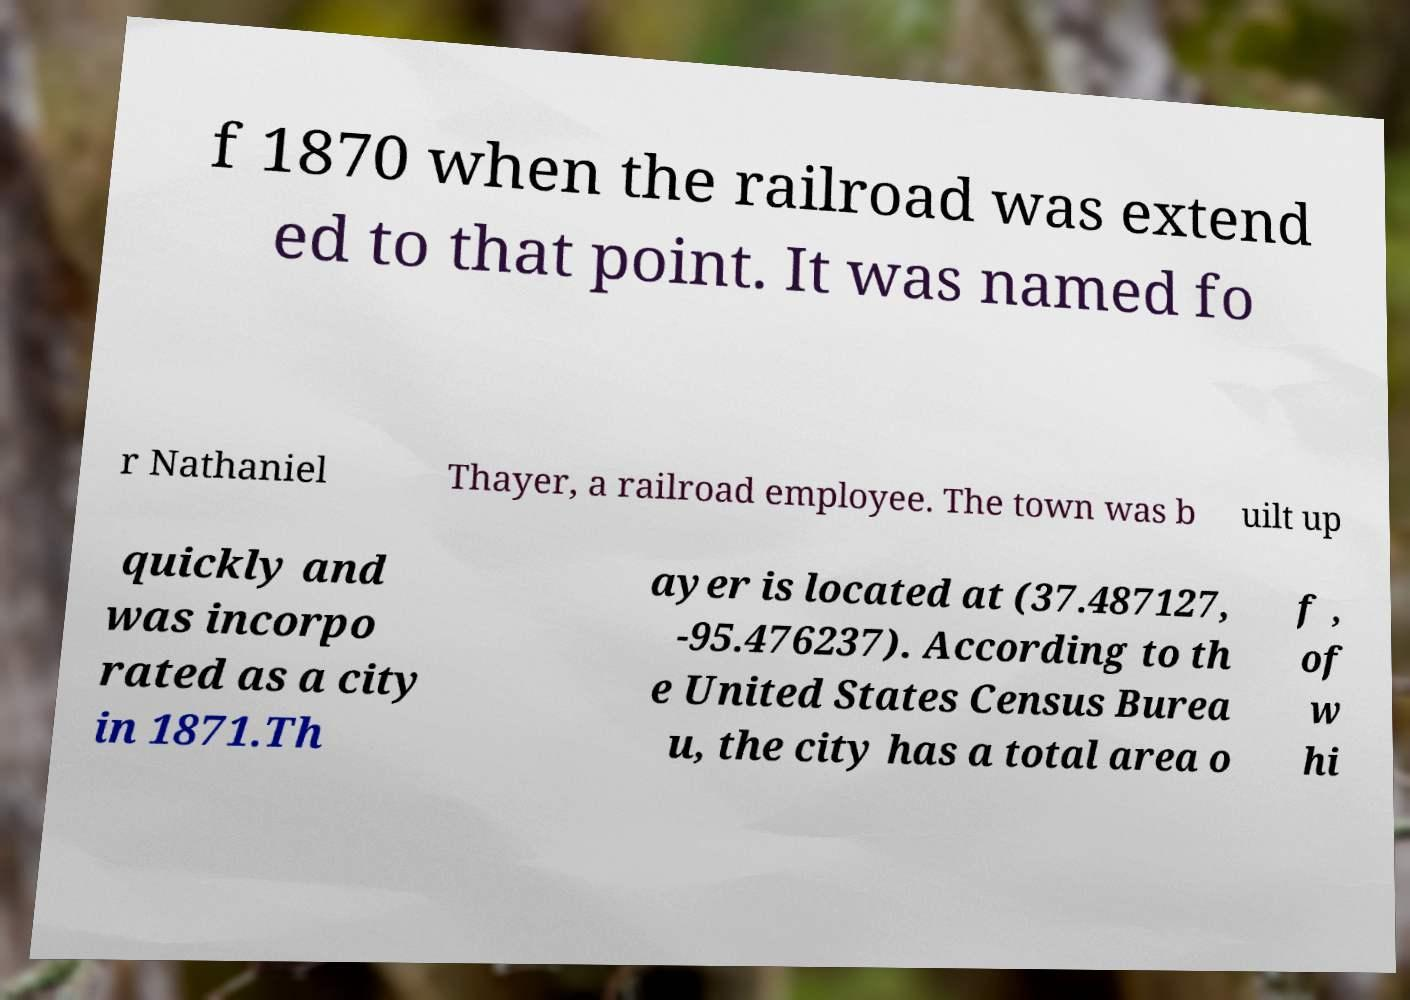Can you accurately transcribe the text from the provided image for me? f 1870 when the railroad was extend ed to that point. It was named fo r Nathaniel Thayer, a railroad employee. The town was b uilt up quickly and was incorpo rated as a city in 1871.Th ayer is located at (37.487127, -95.476237). According to th e United States Census Burea u, the city has a total area o f , of w hi 